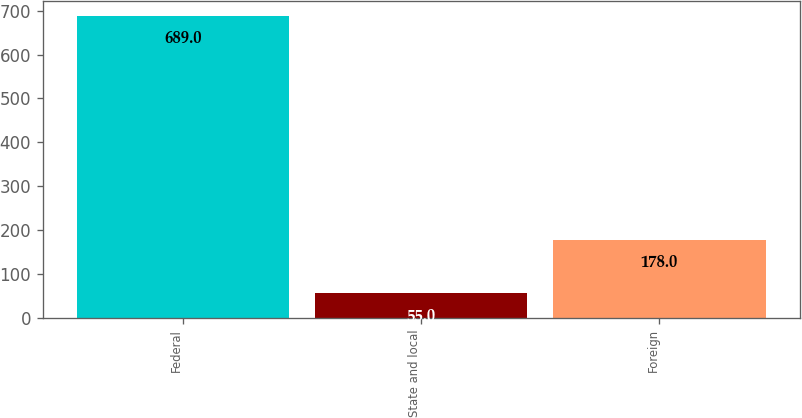Convert chart. <chart><loc_0><loc_0><loc_500><loc_500><bar_chart><fcel>Federal<fcel>State and local<fcel>Foreign<nl><fcel>689<fcel>55<fcel>178<nl></chart> 